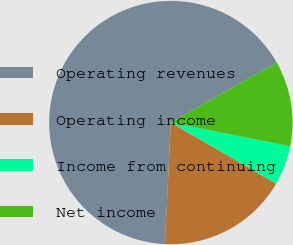Convert chart to OTSL. <chart><loc_0><loc_0><loc_500><loc_500><pie_chart><fcel>Operating revenues<fcel>Operating income<fcel>Income from continuing<fcel>Net income<nl><fcel>66.01%<fcel>17.41%<fcel>5.26%<fcel>11.33%<nl></chart> 